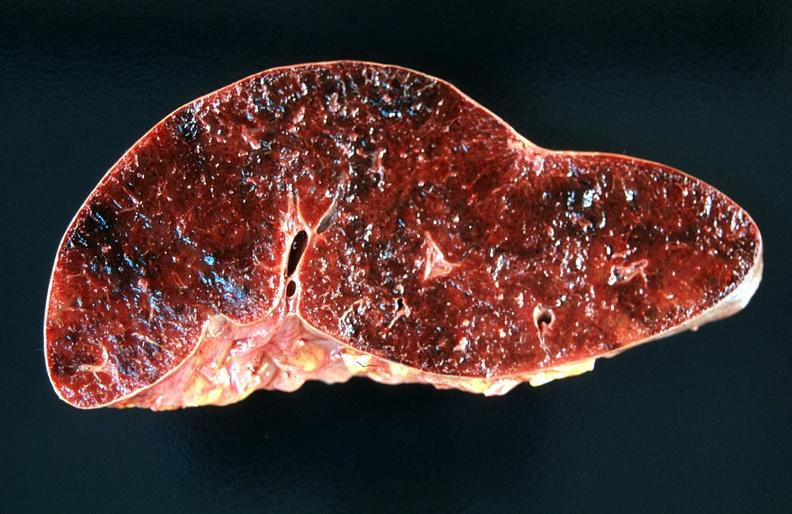s spina bifida present?
Answer the question using a single word or phrase. No 